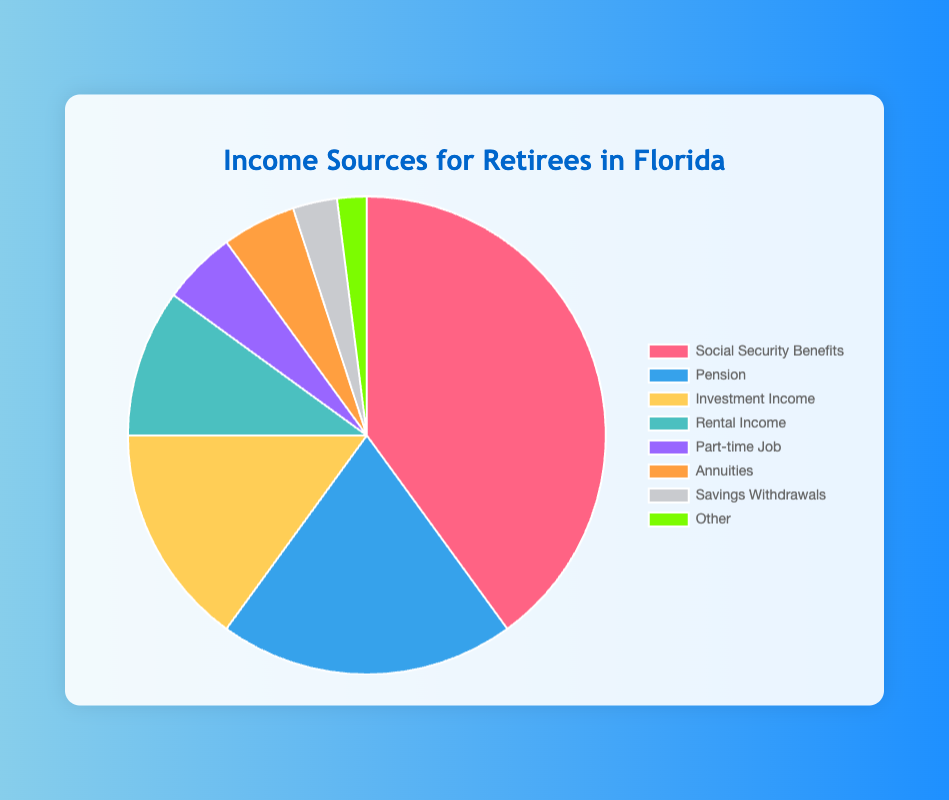What is the largest source of income for retirees in Florida? By looking at the pie chart, the largest segment represents the biggest source. The segment for "Social Security Benefits" is the largest.
Answer: Social Security Benefits What is the combined percentage of Pension and Investment Income? The pie chart shows the percentage of each income source. The percentages for Pension and Investment Income are 20% and 15% respectively. Adding these gives 20% + 15% = 35%.
Answer: 35% Which income source is equal to the sum of Annuities and Savings Withdrawals? From the chart, Annuities account for 5% and Savings Withdrawals account for 3%. Their sum is 5% + 3% = 8%. The only income source with 8% is not explicitly present, but the closest is the categories Other (2%) or slightly more than 5% categories. None equal exactly.
Answer: None How does the percentage of Part-time Job income compare to Rental Income? Part-time Job income is 5% and Rental Income is 10%. Hence, Rental Income is double the percentage of Part-time Job income.
Answer: Rental Income is double Part-time Job income Which income source is represented by the red color in the pie chart? Observing the chart, the red segment corresponds to "Social Security Benefits."
Answer: Social Security Benefits How many income sources are below 10%? By visual inspection, the categories with less than 10% are Part-time Job (5%), Annuities (5%), Savings Withdrawals (3%), and Other (2%). There are 4 such income sources.
Answer: 4 What percentage of income is obtained from sources other than Social Security Benefits and Pension? Social Security Benefits and Pension add up to 40% + 20% = 60%. Therefore, the remaining income sources constitute 100% - 60% = 40%.
Answer: 40% Is the Investment Income larger or smaller than the combination of Annuities and Savings Withdrawals? Investment Income is 15%. Annuities and Savings Withdrawals combined are 5% + 3% = 8%. Therefore, Investment Income is larger.
Answer: Larger If a retiree has an income of $3000, how much would likely come from the Pension? Pension makes up 20% of the income sources. To find 20% of $3000, calculate 3000 * 0.20 = $600.
Answer: $600 